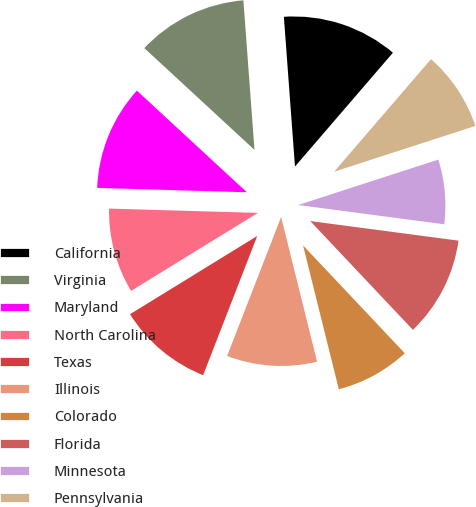<chart> <loc_0><loc_0><loc_500><loc_500><pie_chart><fcel>California<fcel>Virginia<fcel>Maryland<fcel>North Carolina<fcel>Texas<fcel>Illinois<fcel>Colorado<fcel>Florida<fcel>Minnesota<fcel>Pennsylvania<nl><fcel>12.49%<fcel>11.95%<fcel>11.41%<fcel>9.24%<fcel>10.32%<fcel>9.78%<fcel>8.16%<fcel>10.87%<fcel>7.08%<fcel>8.7%<nl></chart> 